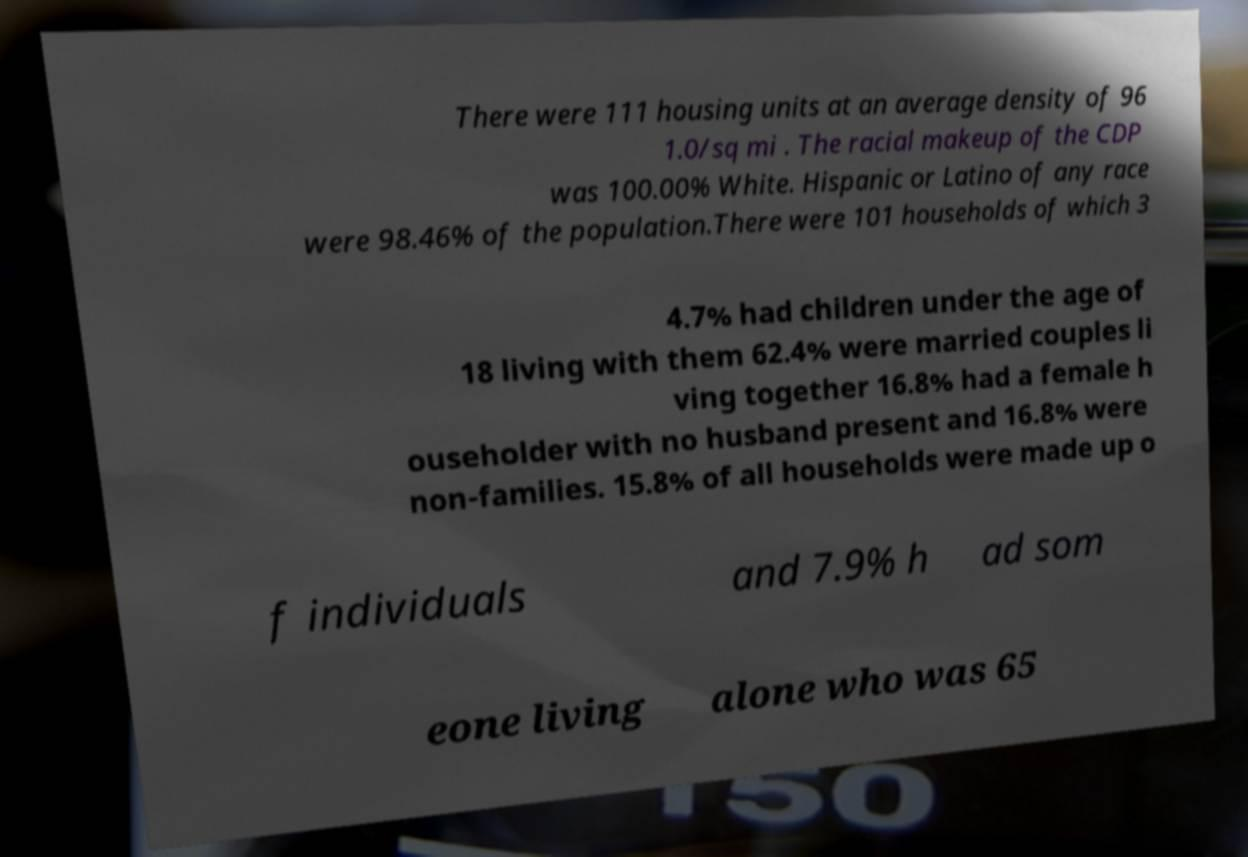What messages or text are displayed in this image? I need them in a readable, typed format. There were 111 housing units at an average density of 96 1.0/sq mi . The racial makeup of the CDP was 100.00% White. Hispanic or Latino of any race were 98.46% of the population.There were 101 households of which 3 4.7% had children under the age of 18 living with them 62.4% were married couples li ving together 16.8% had a female h ouseholder with no husband present and 16.8% were non-families. 15.8% of all households were made up o f individuals and 7.9% h ad som eone living alone who was 65 